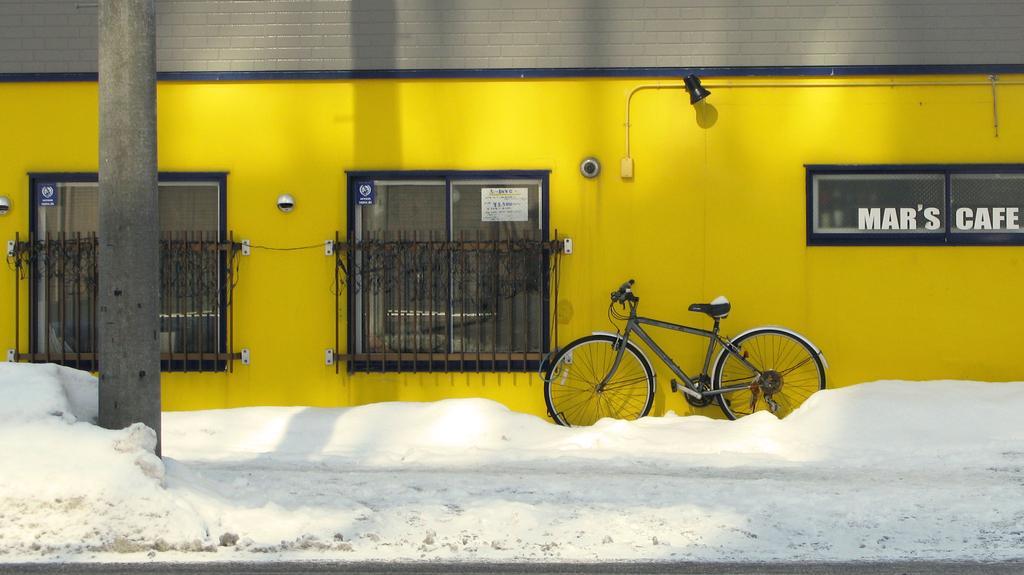In one or two sentences, can you explain what this image depicts? In the image we can see there is a bicycle on the footpath and the footpath is covered with snow and there is a wall which is in yellow colour. 